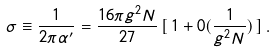<formula> <loc_0><loc_0><loc_500><loc_500>\sigma \equiv \frac { 1 } { 2 \pi \alpha ^ { \prime } } = \frac { 1 6 \pi g ^ { 2 } N } { 2 7 } \, [ \, 1 + 0 ( \frac { 1 } { g ^ { 2 } N } ) \, ] \, .</formula> 